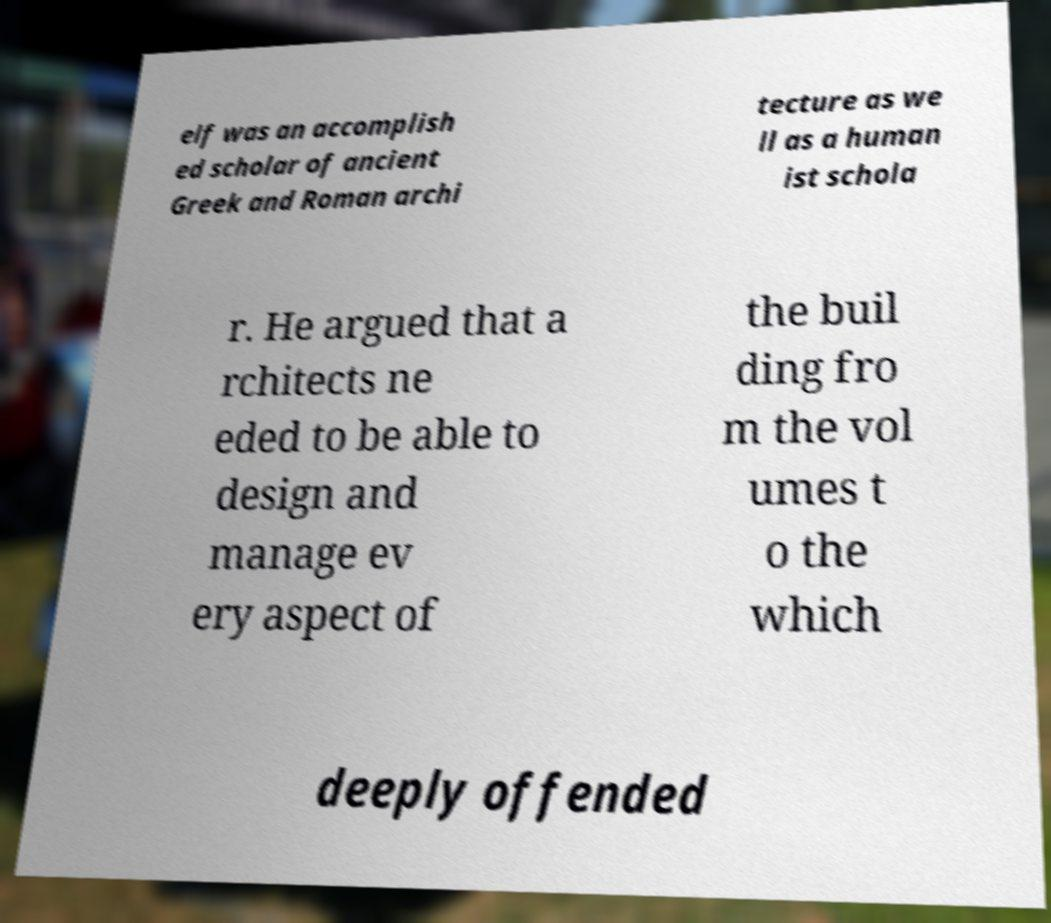There's text embedded in this image that I need extracted. Can you transcribe it verbatim? elf was an accomplish ed scholar of ancient Greek and Roman archi tecture as we ll as a human ist schola r. He argued that a rchitects ne eded to be able to design and manage ev ery aspect of the buil ding fro m the vol umes t o the which deeply offended 